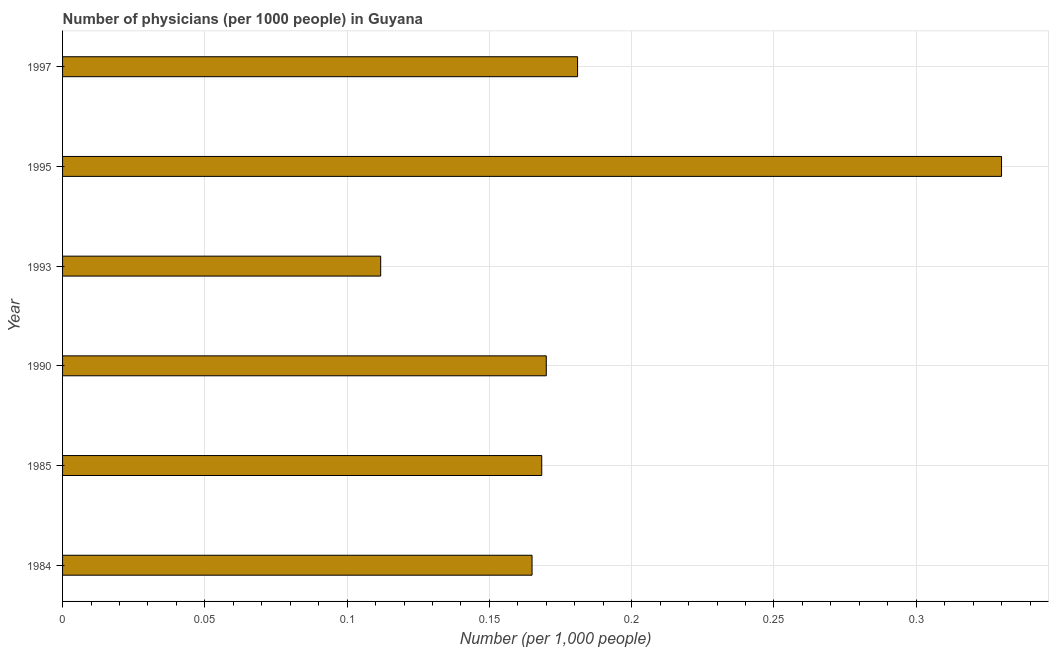Does the graph contain grids?
Ensure brevity in your answer.  Yes. What is the title of the graph?
Your answer should be very brief. Number of physicians (per 1000 people) in Guyana. What is the label or title of the X-axis?
Provide a short and direct response. Number (per 1,0 people). What is the number of physicians in 1985?
Keep it short and to the point. 0.17. Across all years, what is the maximum number of physicians?
Your answer should be compact. 0.33. Across all years, what is the minimum number of physicians?
Keep it short and to the point. 0.11. In which year was the number of physicians minimum?
Your answer should be very brief. 1993. What is the sum of the number of physicians?
Keep it short and to the point. 1.13. What is the difference between the number of physicians in 1984 and 1997?
Offer a very short reply. -0.02. What is the average number of physicians per year?
Make the answer very short. 0.19. What is the median number of physicians?
Give a very brief answer. 0.17. What is the ratio of the number of physicians in 1995 to that in 1997?
Offer a terse response. 1.82. Is the number of physicians in 1995 less than that in 1997?
Offer a terse response. No. What is the difference between the highest and the second highest number of physicians?
Make the answer very short. 0.15. Is the sum of the number of physicians in 1984 and 1993 greater than the maximum number of physicians across all years?
Make the answer very short. No. What is the difference between the highest and the lowest number of physicians?
Keep it short and to the point. 0.22. In how many years, is the number of physicians greater than the average number of physicians taken over all years?
Provide a short and direct response. 1. How many bars are there?
Your answer should be very brief. 6. What is the Number (per 1,000 people) of 1984?
Keep it short and to the point. 0.17. What is the Number (per 1,000 people) in 1985?
Your answer should be very brief. 0.17. What is the Number (per 1,000 people) of 1990?
Make the answer very short. 0.17. What is the Number (per 1,000 people) in 1993?
Keep it short and to the point. 0.11. What is the Number (per 1,000 people) in 1995?
Make the answer very short. 0.33. What is the Number (per 1,000 people) in 1997?
Keep it short and to the point. 0.18. What is the difference between the Number (per 1,000 people) in 1984 and 1985?
Provide a short and direct response. -0. What is the difference between the Number (per 1,000 people) in 1984 and 1990?
Your answer should be very brief. -0.01. What is the difference between the Number (per 1,000 people) in 1984 and 1993?
Offer a very short reply. 0.05. What is the difference between the Number (per 1,000 people) in 1984 and 1995?
Ensure brevity in your answer.  -0.17. What is the difference between the Number (per 1,000 people) in 1984 and 1997?
Provide a short and direct response. -0.02. What is the difference between the Number (per 1,000 people) in 1985 and 1990?
Give a very brief answer. -0. What is the difference between the Number (per 1,000 people) in 1985 and 1993?
Your response must be concise. 0.06. What is the difference between the Number (per 1,000 people) in 1985 and 1995?
Your answer should be compact. -0.16. What is the difference between the Number (per 1,000 people) in 1985 and 1997?
Make the answer very short. -0.01. What is the difference between the Number (per 1,000 people) in 1990 and 1993?
Your response must be concise. 0.06. What is the difference between the Number (per 1,000 people) in 1990 and 1995?
Provide a succinct answer. -0.16. What is the difference between the Number (per 1,000 people) in 1990 and 1997?
Give a very brief answer. -0.01. What is the difference between the Number (per 1,000 people) in 1993 and 1995?
Offer a very short reply. -0.22. What is the difference between the Number (per 1,000 people) in 1993 and 1997?
Keep it short and to the point. -0.07. What is the difference between the Number (per 1,000 people) in 1995 and 1997?
Provide a short and direct response. 0.15. What is the ratio of the Number (per 1,000 people) in 1984 to that in 1985?
Provide a succinct answer. 0.98. What is the ratio of the Number (per 1,000 people) in 1984 to that in 1993?
Provide a short and direct response. 1.48. What is the ratio of the Number (per 1,000 people) in 1984 to that in 1995?
Make the answer very short. 0.5. What is the ratio of the Number (per 1,000 people) in 1984 to that in 1997?
Your response must be concise. 0.91. What is the ratio of the Number (per 1,000 people) in 1985 to that in 1990?
Offer a very short reply. 0.99. What is the ratio of the Number (per 1,000 people) in 1985 to that in 1993?
Provide a succinct answer. 1.51. What is the ratio of the Number (per 1,000 people) in 1985 to that in 1995?
Offer a very short reply. 0.51. What is the ratio of the Number (per 1,000 people) in 1985 to that in 1997?
Make the answer very short. 0.93. What is the ratio of the Number (per 1,000 people) in 1990 to that in 1993?
Make the answer very short. 1.52. What is the ratio of the Number (per 1,000 people) in 1990 to that in 1995?
Ensure brevity in your answer.  0.52. What is the ratio of the Number (per 1,000 people) in 1990 to that in 1997?
Provide a succinct answer. 0.94. What is the ratio of the Number (per 1,000 people) in 1993 to that in 1995?
Ensure brevity in your answer.  0.34. What is the ratio of the Number (per 1,000 people) in 1993 to that in 1997?
Keep it short and to the point. 0.62. What is the ratio of the Number (per 1,000 people) in 1995 to that in 1997?
Your answer should be very brief. 1.82. 